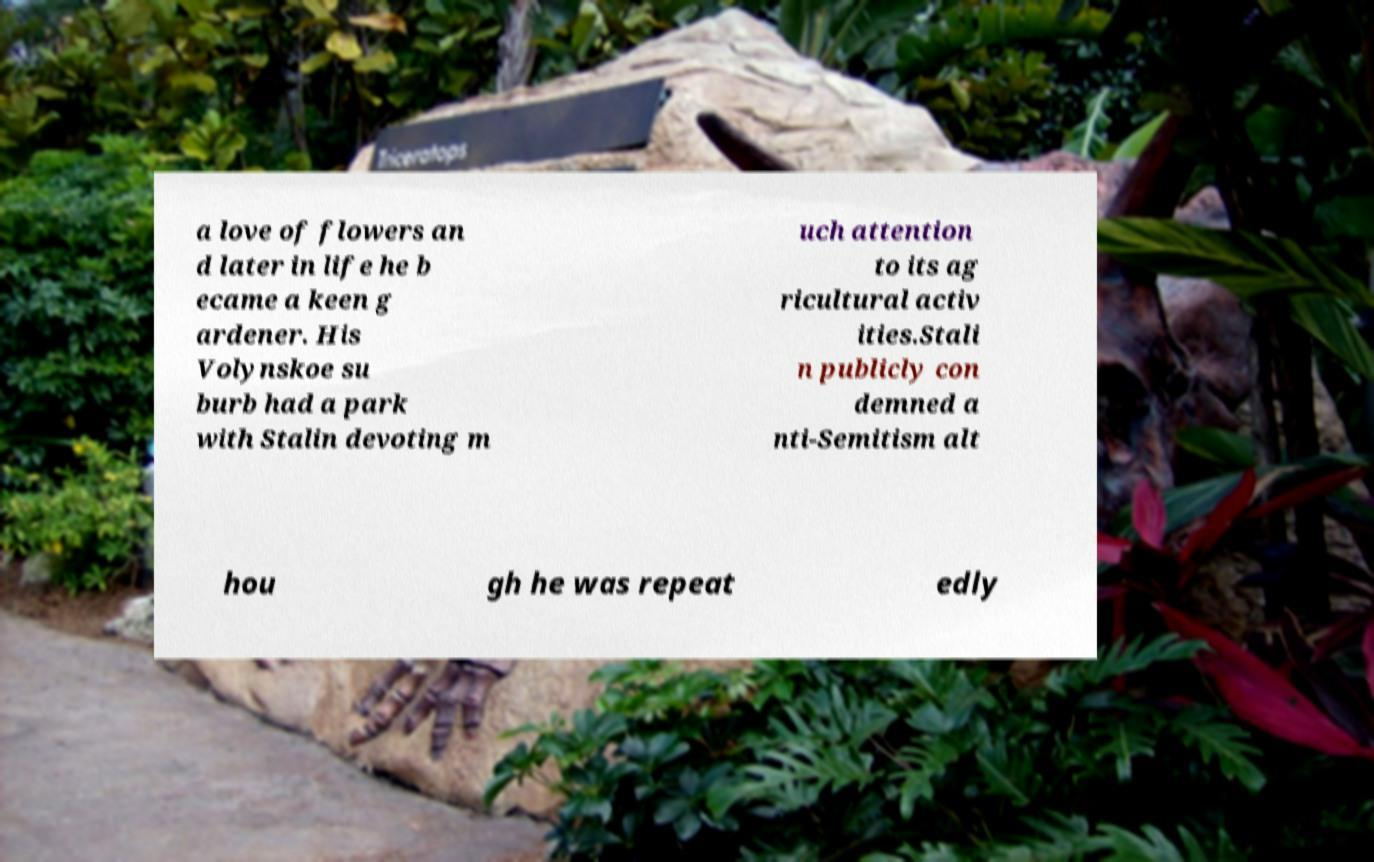Please identify and transcribe the text found in this image. a love of flowers an d later in life he b ecame a keen g ardener. His Volynskoe su burb had a park with Stalin devoting m uch attention to its ag ricultural activ ities.Stali n publicly con demned a nti-Semitism alt hou gh he was repeat edly 